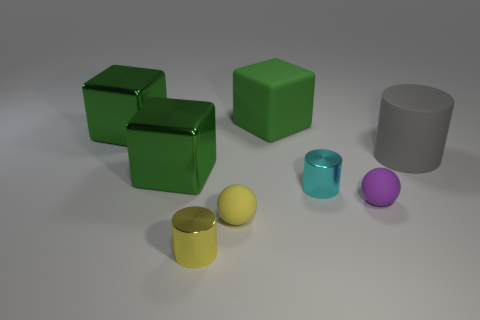How many green blocks must be subtracted to get 1 green blocks? 2 Add 2 yellow shiny objects. How many objects exist? 10 Subtract all cubes. How many objects are left? 5 Subtract 0 purple cubes. How many objects are left? 8 Subtract all big purple metallic cubes. Subtract all big green metallic cubes. How many objects are left? 6 Add 4 green blocks. How many green blocks are left? 7 Add 8 shiny spheres. How many shiny spheres exist? 8 